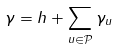Convert formula to latex. <formula><loc_0><loc_0><loc_500><loc_500>\gamma = h + \sum _ { u \in \mathcal { P } } \gamma _ { u }</formula> 